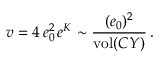Convert formula to latex. <formula><loc_0><loc_0><loc_500><loc_500>v = 4 \, e _ { 0 } ^ { 2 } \, e ^ { K } \sim { \frac { ( e _ { 0 } ) ^ { 2 } } { v o l ( C Y ) } } \, .</formula> 